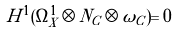Convert formula to latex. <formula><loc_0><loc_0><loc_500><loc_500>H ^ { 1 } ( \Omega _ { X } ^ { 1 } \otimes N _ { C } \otimes \omega _ { C } ) = 0</formula> 